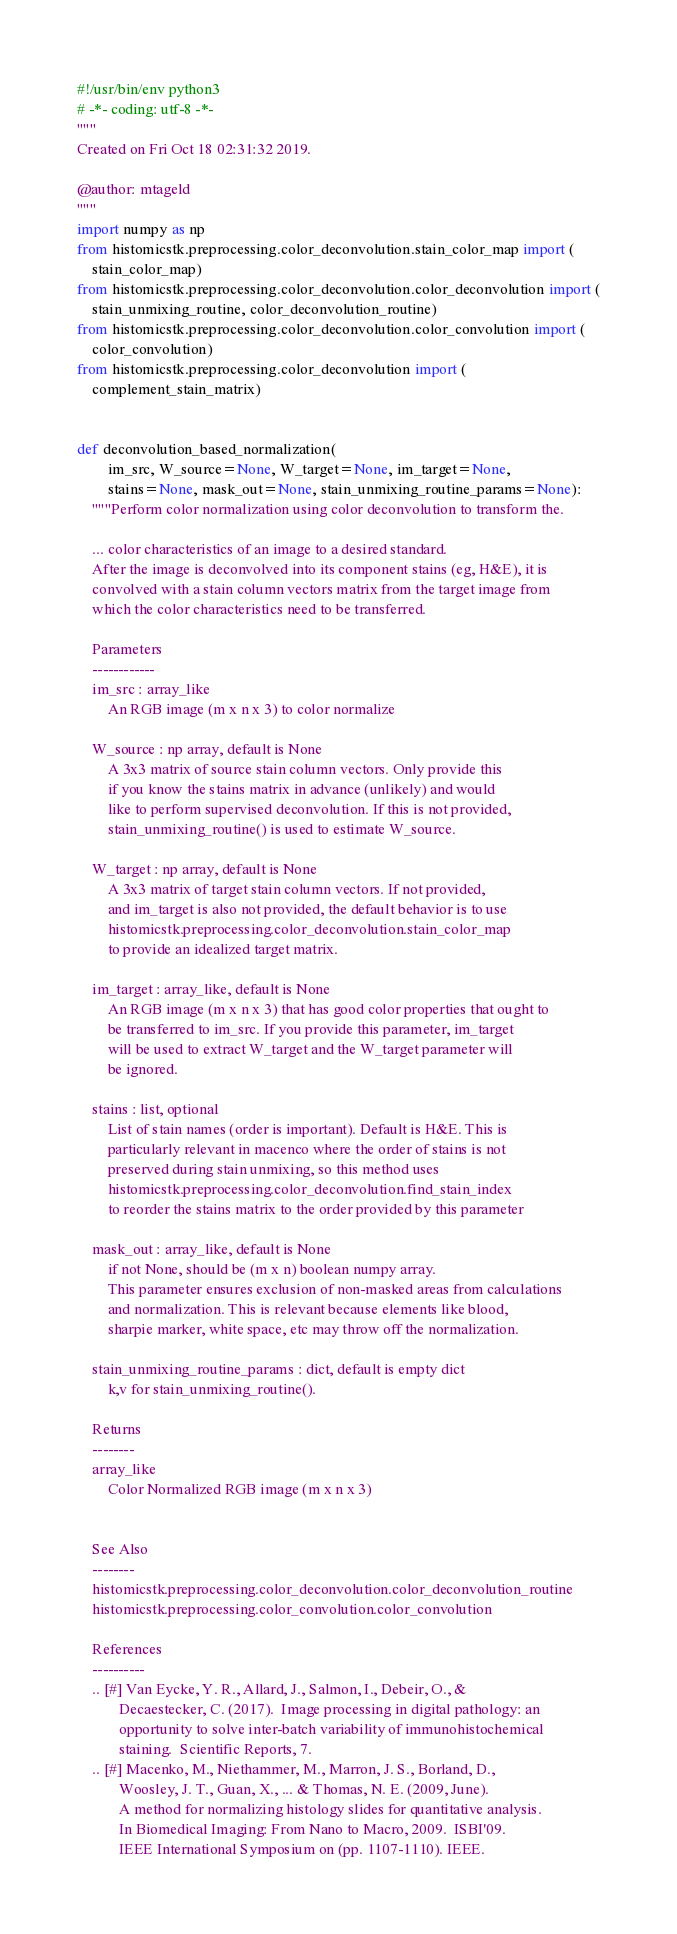<code> <loc_0><loc_0><loc_500><loc_500><_Python_>#!/usr/bin/env python3
# -*- coding: utf-8 -*-
"""
Created on Fri Oct 18 02:31:32 2019.

@author: mtageld
"""
import numpy as np
from histomicstk.preprocessing.color_deconvolution.stain_color_map import (
    stain_color_map)
from histomicstk.preprocessing.color_deconvolution.color_deconvolution import (
    stain_unmixing_routine, color_deconvolution_routine)
from histomicstk.preprocessing.color_deconvolution.color_convolution import (
    color_convolution)
from histomicstk.preprocessing.color_deconvolution import (
    complement_stain_matrix)


def deconvolution_based_normalization(
        im_src, W_source=None, W_target=None, im_target=None,
        stains=None, mask_out=None, stain_unmixing_routine_params=None):
    """Perform color normalization using color deconvolution to transform the.

    ... color characteristics of an image to a desired standard.
    After the image is deconvolved into its component stains (eg, H&E), it is
    convolved with a stain column vectors matrix from the target image from
    which the color characteristics need to be transferred.

    Parameters
    ------------
    im_src : array_like
        An RGB image (m x n x 3) to color normalize

    W_source : np array, default is None
        A 3x3 matrix of source stain column vectors. Only provide this
        if you know the stains matrix in advance (unlikely) and would
        like to perform supervised deconvolution. If this is not provided,
        stain_unmixing_routine() is used to estimate W_source.

    W_target : np array, default is None
        A 3x3 matrix of target stain column vectors. If not provided,
        and im_target is also not provided, the default behavior is to use
        histomicstk.preprocessing.color_deconvolution.stain_color_map
        to provide an idealized target matrix.

    im_target : array_like, default is None
        An RGB image (m x n x 3) that has good color properties that ought to
        be transferred to im_src. If you provide this parameter, im_target
        will be used to extract W_target and the W_target parameter will
        be ignored.

    stains : list, optional
        List of stain names (order is important). Default is H&E. This is
        particularly relevant in macenco where the order of stains is not
        preserved during stain unmixing, so this method uses
        histomicstk.preprocessing.color_deconvolution.find_stain_index
        to reorder the stains matrix to the order provided by this parameter

    mask_out : array_like, default is None
        if not None, should be (m x n) boolean numpy array.
        This parameter ensures exclusion of non-masked areas from calculations
        and normalization. This is relevant because elements like blood,
        sharpie marker, white space, etc may throw off the normalization.

    stain_unmixing_routine_params : dict, default is empty dict
        k,v for stain_unmixing_routine().

    Returns
    --------
    array_like
        Color Normalized RGB image (m x n x 3)


    See Also
    --------
    histomicstk.preprocessing.color_deconvolution.color_deconvolution_routine
    histomicstk.preprocessing.color_convolution.color_convolution

    References
    ----------
    .. [#] Van Eycke, Y. R., Allard, J., Salmon, I., Debeir, O., &
           Decaestecker, C. (2017).  Image processing in digital pathology: an
           opportunity to solve inter-batch variability of immunohistochemical
           staining.  Scientific Reports, 7.
    .. [#] Macenko, M., Niethammer, M., Marron, J. S., Borland, D.,
           Woosley, J. T., Guan, X., ... & Thomas, N. E. (2009, June).
           A method for normalizing histology slides for quantitative analysis.
           In Biomedical Imaging: From Nano to Macro, 2009.  ISBI'09.
           IEEE International Symposium on (pp. 1107-1110). IEEE.</code> 